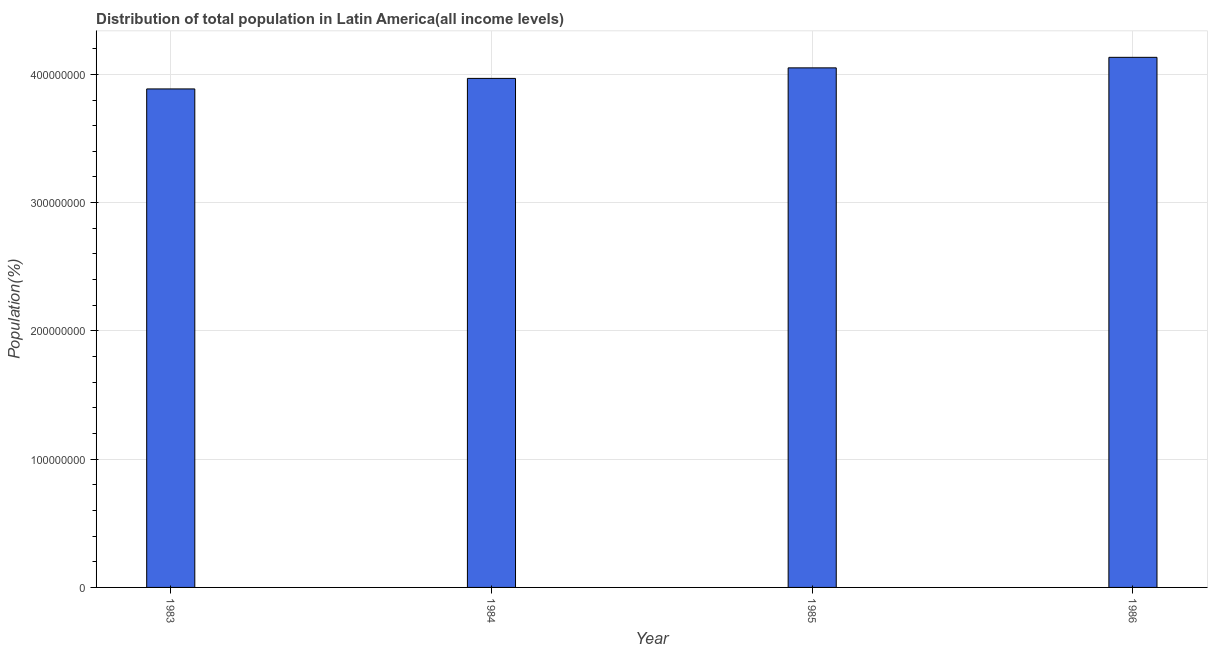What is the title of the graph?
Offer a very short reply. Distribution of total population in Latin America(all income levels) . What is the label or title of the X-axis?
Ensure brevity in your answer.  Year. What is the label or title of the Y-axis?
Provide a short and direct response. Population(%). What is the population in 1983?
Ensure brevity in your answer.  3.89e+08. Across all years, what is the maximum population?
Make the answer very short. 4.13e+08. Across all years, what is the minimum population?
Give a very brief answer. 3.89e+08. In which year was the population maximum?
Give a very brief answer. 1986. What is the sum of the population?
Keep it short and to the point. 1.60e+09. What is the difference between the population in 1984 and 1985?
Keep it short and to the point. -8.21e+06. What is the average population per year?
Your response must be concise. 4.01e+08. What is the median population?
Your response must be concise. 4.01e+08. Do a majority of the years between 1986 and 1983 (inclusive) have population greater than 180000000 %?
Provide a succinct answer. Yes. What is the ratio of the population in 1985 to that in 1986?
Your answer should be compact. 0.98. Is the difference between the population in 1984 and 1986 greater than the difference between any two years?
Your answer should be very brief. No. What is the difference between the highest and the second highest population?
Your answer should be very brief. 8.21e+06. What is the difference between the highest and the lowest population?
Ensure brevity in your answer.  2.46e+07. In how many years, is the population greater than the average population taken over all years?
Offer a terse response. 2. How many years are there in the graph?
Give a very brief answer. 4. Are the values on the major ticks of Y-axis written in scientific E-notation?
Provide a succinct answer. No. What is the Population(%) of 1983?
Provide a short and direct response. 3.89e+08. What is the Population(%) of 1984?
Your answer should be compact. 3.97e+08. What is the Population(%) in 1985?
Offer a very short reply. 4.05e+08. What is the Population(%) of 1986?
Your answer should be compact. 4.13e+08. What is the difference between the Population(%) in 1983 and 1984?
Ensure brevity in your answer.  -8.22e+06. What is the difference between the Population(%) in 1983 and 1985?
Give a very brief answer. -1.64e+07. What is the difference between the Population(%) in 1983 and 1986?
Provide a short and direct response. -2.46e+07. What is the difference between the Population(%) in 1984 and 1985?
Your answer should be compact. -8.21e+06. What is the difference between the Population(%) in 1984 and 1986?
Your answer should be compact. -1.64e+07. What is the difference between the Population(%) in 1985 and 1986?
Keep it short and to the point. -8.21e+06. What is the ratio of the Population(%) in 1983 to that in 1984?
Make the answer very short. 0.98. What is the ratio of the Population(%) in 1984 to that in 1985?
Your answer should be very brief. 0.98. 